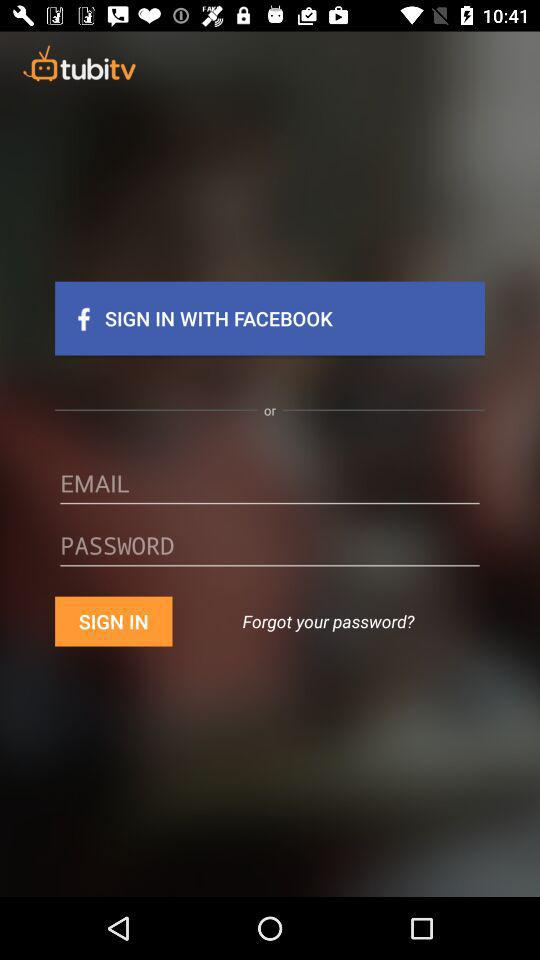What is the email address?
When the provided information is insufficient, respond with <no answer>. <no answer> 